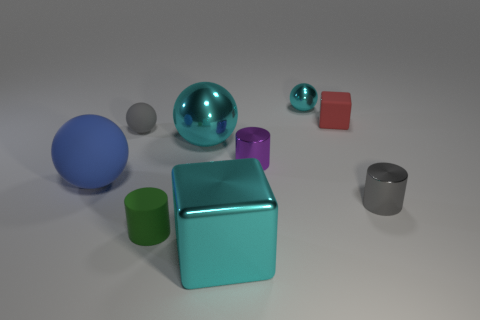There is a cube behind the tiny purple cylinder; what is its material?
Your response must be concise. Rubber. What size is the metallic cylinder that is the same color as the small matte ball?
Make the answer very short. Small. How many things are either balls behind the matte block or tiny gray blocks?
Make the answer very short. 1. Is the number of purple things that are to the left of the large blue thing the same as the number of blue rubber objects?
Offer a terse response. No. Is the size of the blue object the same as the red rubber block?
Make the answer very short. No. What is the color of the shiny cube that is the same size as the blue rubber object?
Provide a short and direct response. Cyan. There is a red block; is it the same size as the cyan thing in front of the big blue matte thing?
Give a very brief answer. No. What number of objects are the same color as the big shiny ball?
Provide a short and direct response. 2. What number of things are small cylinders or large objects that are behind the tiny gray shiny cylinder?
Make the answer very short. 5. There is a metallic object behind the small gray ball; is its size the same as the blue rubber ball behind the small gray metallic object?
Provide a short and direct response. No. 